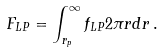Convert formula to latex. <formula><loc_0><loc_0><loc_500><loc_500>F _ { L P } = \int ^ { \infty } _ { r _ { p } } f _ { L P } 2 \pi r d r \, .</formula> 